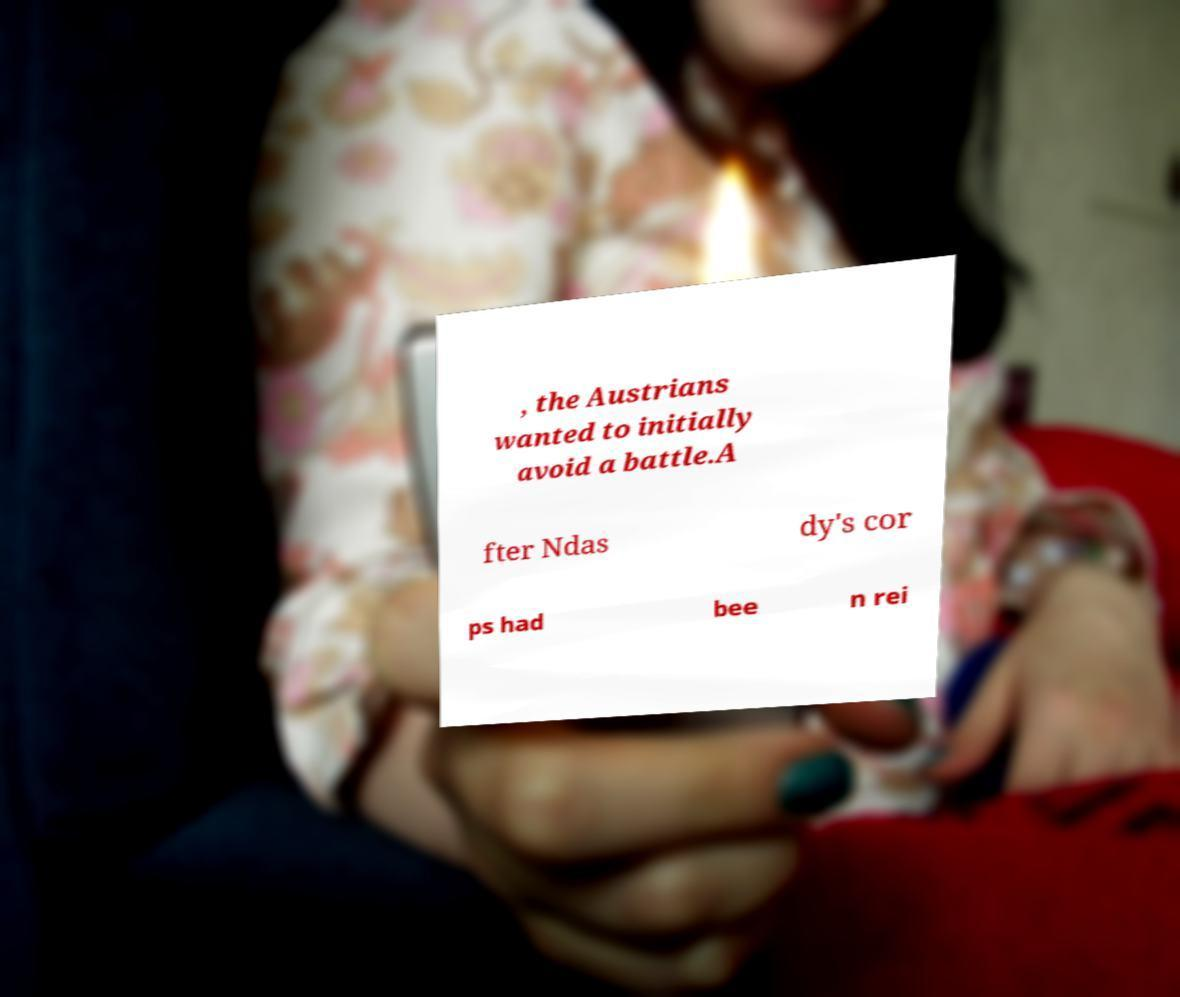Please identify and transcribe the text found in this image. , the Austrians wanted to initially avoid a battle.A fter Ndas dy's cor ps had bee n rei 